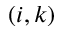Convert formula to latex. <formula><loc_0><loc_0><loc_500><loc_500>( i , k )</formula> 